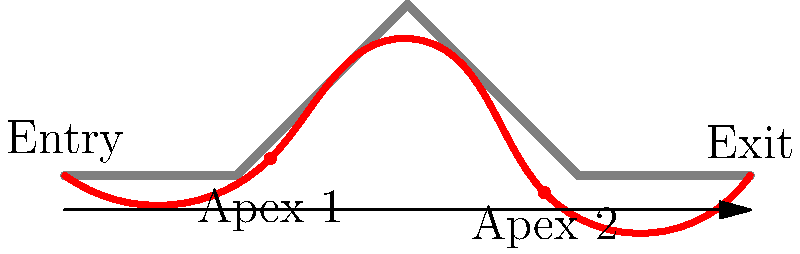In the diagram above, which represents a chicane on a Formula 1 track, what key characteristic of the optimal racing line (shown in red) allows drivers to maintain the highest possible speed through this corner complex? To understand the optimal racing line through a chicane, let's break down the key elements:

1. Entry: The racing line starts wide, allowing the driver to straighten the first part of the corner.

2. First apex: The line moves towards the inside of the track at the first turn of the chicane. This is earlier than the geometric apex of the corner, known as an early apex.

3. Middle section: Between the two turns of the chicane, the line moves towards the outside of the track. This creates a straighter path and allows for better acceleration.

4. Second apex: The line then moves back towards the inside for the second turn of the chicane. This apex is typically later than the geometric apex, known as a late apex.

5. Exit: The line moves to the outside of the track on exit, allowing for full acceleration out of the corner.

The key characteristic that allows drivers to maintain the highest possible speed is the smoothness of the line. By taking a wider, smoother path through the chicane, drivers can:

a) Minimize the steering angle, which helps maintain speed
b) Reduce the number of directional changes, which is less disruptive to the car's balance
c) Create a more gradual acceleration and deceleration profile

This smooth, wide line effectively "straightens" the chicane as much as possible, allowing drivers to carry more speed through the corner complex compared to a tighter, more angular line that closely follows the track's edges.
Answer: Smooth, wide path that "straightens" the chicane 